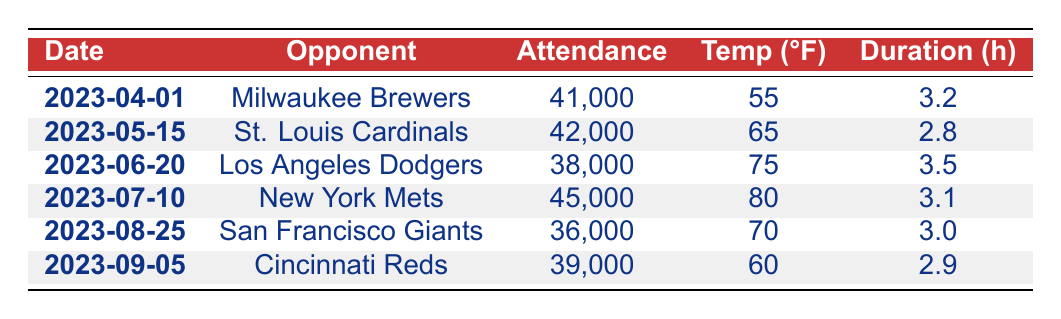What is the attendance of the game on April 1, 2023? The table shows that the attendance for the game against the Milwaukee Brewers on April 1, 2023, is 41,000.
Answer: 41,000 What was the highest attendance recorded in 2023? To find the highest attendance, we look through the attendance figures: 41,000, 42,000, 38,000, 45,000, 36,000, and 39,000. The highest among these is 45,000 for the game against the New York Mets on July 10, 2023.
Answer: 45,000 What was the average temperature during the games in 2023? The temperatures recorded are 55, 65, 75, 80, 70, and 60. We calculate the average as follows: (55 + 65 + 75 + 80 + 70 + 60) / 6 = 66.67.
Answer: 66.67 Did the Cubs have a game against the San Francisco Giants in 2023? According to the table, there was a game against the San Francisco Giants on August 25, 2023. This confirms that they did have a game against this team.
Answer: Yes What is the difference in attendance between the game with the highest and the game with the lowest attendance? The highest attendance is 45,000 (New York Mets) and the lowest is 36,000 (San Francisco Giants). The difference is 45,000 - 36,000 = 9,000.
Answer: 9,000 Which game had the longest duration and what was that duration? The game with the longest duration was against the Los Angeles Dodgers on June 20, 2023, which lasted for 3.5 hours. We determine this by comparing the durations listed: 3.2, 2.8, 3.5, 3.1, 3.0, and 2.9, with 3.5 being the longest.
Answer: 3.5 What was the average attendance for the baseball games in 2023? The attendances recorded are 41,000, 42,000, 38,000, 45,000, 36,000, and 39,000. The total attendance is 41,000 + 42,000 + 38,000 + 45,000 + 36,000 + 39,000 = 241,000. Dividing this by the 6 games gives an average of 241,000 / 6 = 40,166.67.
Answer: 40,166.67 Was the attendance for the game against the Cincinnati Reds greater than 40,000? The attendance for the game against the Cincinnati Reds on September 5, 2023, is 39,000. Since 39,000 is less than 40,000, we conclude that it was not greater.
Answer: No What day had a temperature of 80°F? According to the table, the game on July 10, 2023, had a temperature of 80°F.
Answer: July 10, 2023 